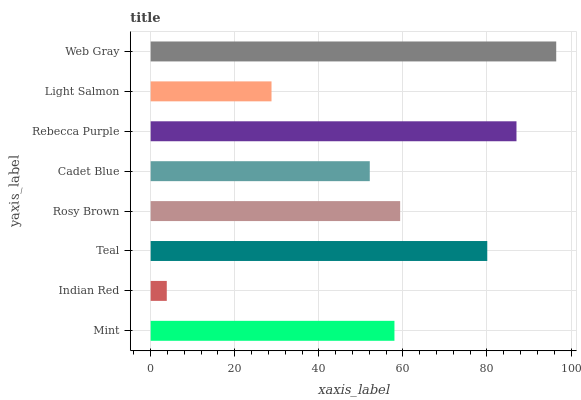Is Indian Red the minimum?
Answer yes or no. Yes. Is Web Gray the maximum?
Answer yes or no. Yes. Is Teal the minimum?
Answer yes or no. No. Is Teal the maximum?
Answer yes or no. No. Is Teal greater than Indian Red?
Answer yes or no. Yes. Is Indian Red less than Teal?
Answer yes or no. Yes. Is Indian Red greater than Teal?
Answer yes or no. No. Is Teal less than Indian Red?
Answer yes or no. No. Is Rosy Brown the high median?
Answer yes or no. Yes. Is Mint the low median?
Answer yes or no. Yes. Is Teal the high median?
Answer yes or no. No. Is Teal the low median?
Answer yes or no. No. 